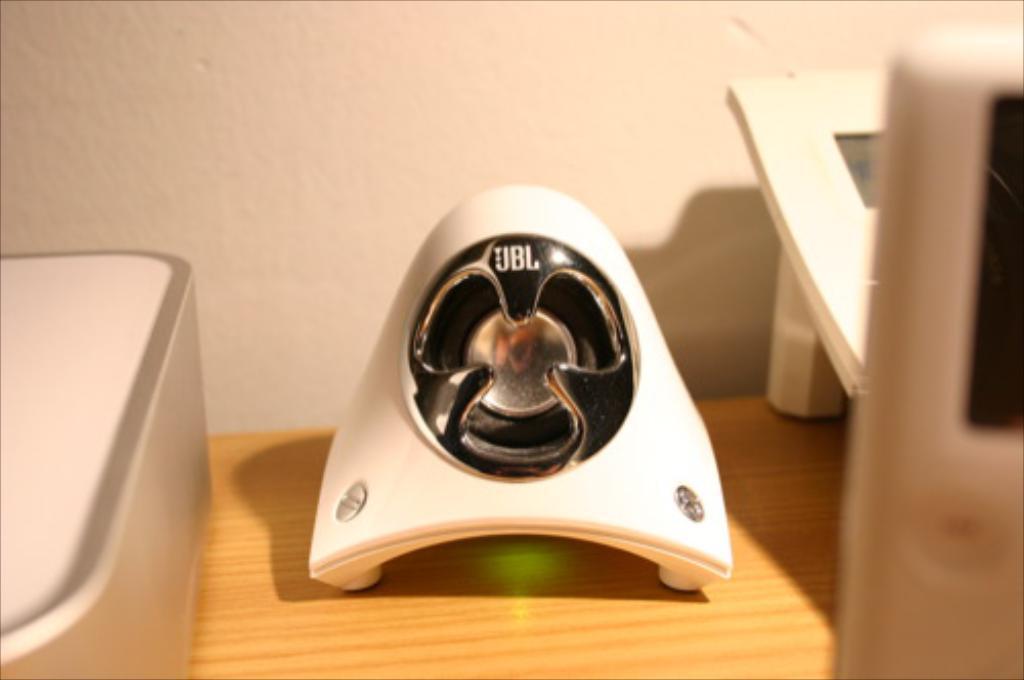Describe this image in one or two sentences. In this picture I can see there is a white collar device and it has a logo on it. It is placed on the wooden table and in the backdrop I can see there is a wall. 